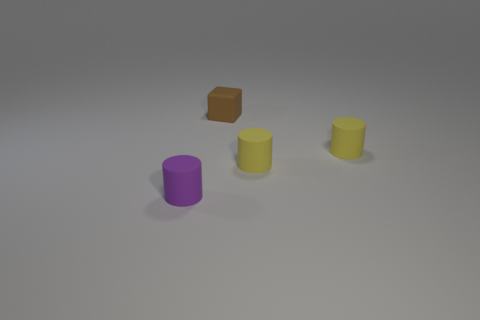Are there more tiny brown objects that are in front of the small brown block than cubes in front of the tiny purple cylinder?
Keep it short and to the point. No. There is a small object that is on the left side of the tiny brown rubber thing; what number of small brown matte things are in front of it?
Offer a very short reply. 0. Are there any large matte things of the same color as the tiny matte block?
Offer a terse response. No. Do the brown rubber object and the purple thing have the same size?
Keep it short and to the point. Yes. There is a matte cylinder that is left of the cube; is its size the same as the brown thing?
Offer a terse response. Yes. What number of matte objects are either yellow objects or small purple objects?
Your answer should be compact. 3. Is the material of the small brown cube the same as the purple thing?
Make the answer very short. Yes. What is the shape of the small brown object?
Provide a short and direct response. Cube. How many things are either tiny yellow cylinders or cylinders that are to the left of the tiny cube?
Offer a terse response. 3. Does the tiny rubber cylinder to the left of the cube have the same color as the cube?
Offer a very short reply. No. 